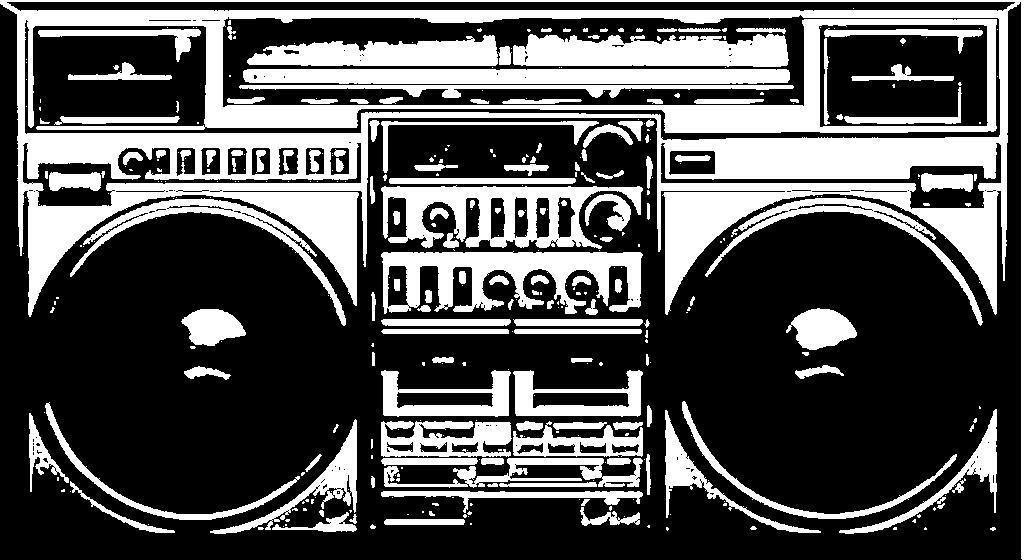Describe this image in one or two sentences. It is the black and white image of a radio. 